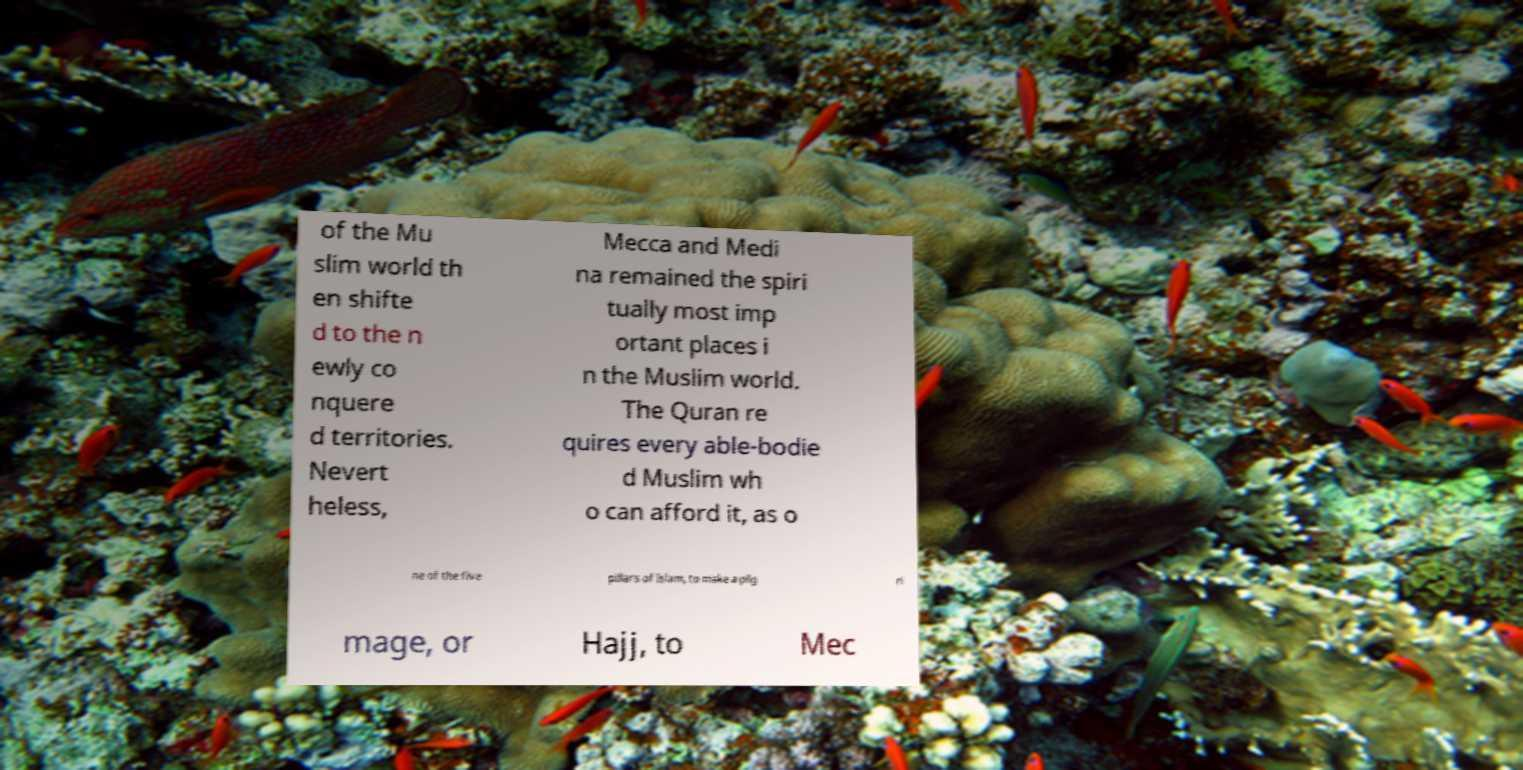Can you read and provide the text displayed in the image?This photo seems to have some interesting text. Can you extract and type it out for me? of the Mu slim world th en shifte d to the n ewly co nquere d territories. Nevert heless, Mecca and Medi na remained the spiri tually most imp ortant places i n the Muslim world. The Quran re quires every able-bodie d Muslim wh o can afford it, as o ne of the five pillars of Islam, to make a pilg ri mage, or Hajj, to Mec 